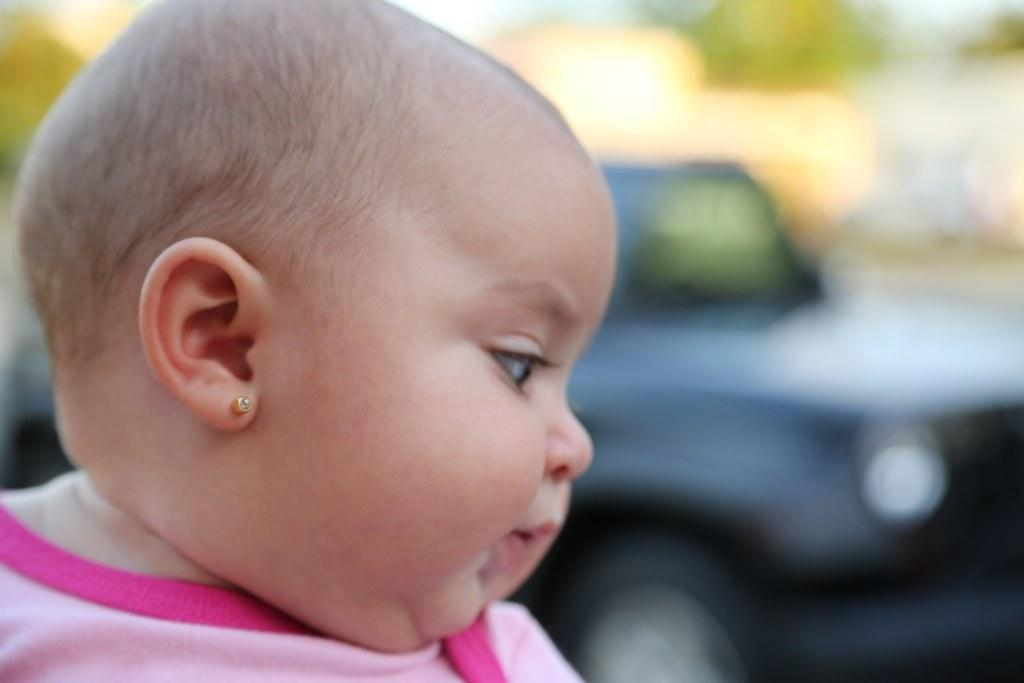What is the main subject of the image? There is a baby girl in the image. What is the baby girl wearing? The baby girl is wearing a pink dress and earrings. Can you describe the background of the image? There is a black color car in the background of the image. Is there a carriage being pulled by a horse in the image? No, there is no carriage or horse present in the image. 